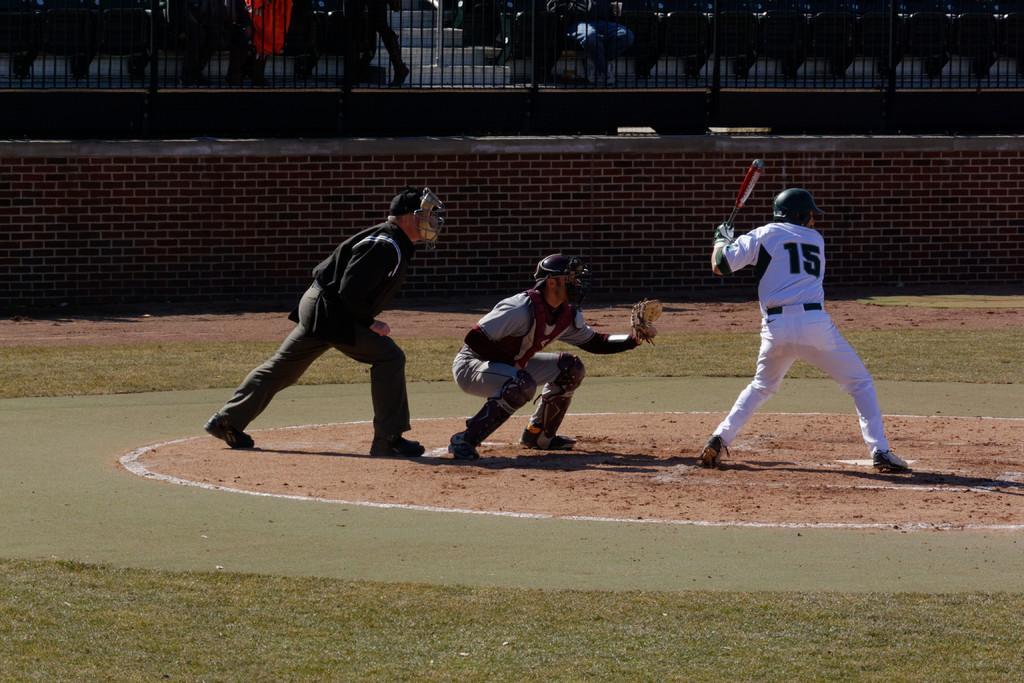Could you give a brief overview of what you see in this image? In this image on the right there is a man, he wears a t shirt, trouser, shoes and helmet, he is holding a bat, behind him there is a man, he wears a t shirt, trouser, shoes and helmet, behind him there is a man, he wears a t shirt, trouser, shoes and helmet. At the bottom there is grass and land. In the background there are chairs, some people, staircase and wall. 